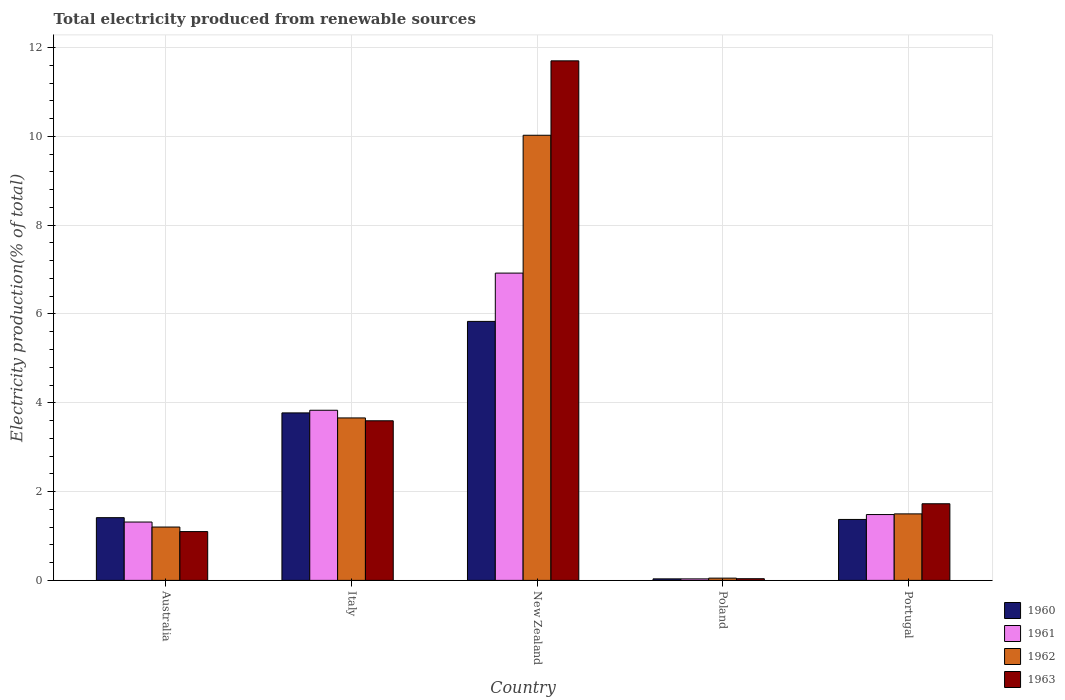Are the number of bars per tick equal to the number of legend labels?
Provide a short and direct response. Yes. Are the number of bars on each tick of the X-axis equal?
Keep it short and to the point. Yes. How many bars are there on the 3rd tick from the left?
Ensure brevity in your answer.  4. What is the total electricity produced in 1960 in Italy?
Make the answer very short. 3.77. Across all countries, what is the maximum total electricity produced in 1963?
Your answer should be very brief. 11.7. Across all countries, what is the minimum total electricity produced in 1963?
Provide a succinct answer. 0.04. In which country was the total electricity produced in 1963 maximum?
Your response must be concise. New Zealand. What is the total total electricity produced in 1961 in the graph?
Provide a short and direct response. 13.58. What is the difference between the total electricity produced in 1962 in Italy and that in Poland?
Your answer should be very brief. 3.61. What is the difference between the total electricity produced in 1960 in New Zealand and the total electricity produced in 1963 in Poland?
Offer a very short reply. 5.79. What is the average total electricity produced in 1961 per country?
Make the answer very short. 2.72. What is the difference between the total electricity produced of/in 1963 and total electricity produced of/in 1962 in Australia?
Provide a succinct answer. -0.1. In how many countries, is the total electricity produced in 1961 greater than 5.6 %?
Give a very brief answer. 1. What is the ratio of the total electricity produced in 1961 in Australia to that in New Zealand?
Offer a very short reply. 0.19. Is the total electricity produced in 1962 in Italy less than that in New Zealand?
Make the answer very short. Yes. Is the difference between the total electricity produced in 1963 in New Zealand and Poland greater than the difference between the total electricity produced in 1962 in New Zealand and Poland?
Your answer should be compact. Yes. What is the difference between the highest and the second highest total electricity produced in 1962?
Ensure brevity in your answer.  -8.53. What is the difference between the highest and the lowest total electricity produced in 1963?
Keep it short and to the point. 11.66. In how many countries, is the total electricity produced in 1962 greater than the average total electricity produced in 1962 taken over all countries?
Make the answer very short. 2. Is the sum of the total electricity produced in 1960 in Italy and Portugal greater than the maximum total electricity produced in 1963 across all countries?
Make the answer very short. No. How many bars are there?
Your answer should be very brief. 20. Are all the bars in the graph horizontal?
Make the answer very short. No. How many countries are there in the graph?
Ensure brevity in your answer.  5. Are the values on the major ticks of Y-axis written in scientific E-notation?
Give a very brief answer. No. Does the graph contain any zero values?
Provide a short and direct response. No. Where does the legend appear in the graph?
Offer a terse response. Bottom right. How many legend labels are there?
Keep it short and to the point. 4. What is the title of the graph?
Provide a succinct answer. Total electricity produced from renewable sources. What is the Electricity production(% of total) of 1960 in Australia?
Ensure brevity in your answer.  1.41. What is the Electricity production(% of total) of 1961 in Australia?
Keep it short and to the point. 1.31. What is the Electricity production(% of total) of 1962 in Australia?
Your answer should be compact. 1.2. What is the Electricity production(% of total) of 1963 in Australia?
Your answer should be compact. 1.1. What is the Electricity production(% of total) of 1960 in Italy?
Ensure brevity in your answer.  3.77. What is the Electricity production(% of total) of 1961 in Italy?
Keep it short and to the point. 3.83. What is the Electricity production(% of total) in 1962 in Italy?
Offer a terse response. 3.66. What is the Electricity production(% of total) of 1963 in Italy?
Your response must be concise. 3.59. What is the Electricity production(% of total) of 1960 in New Zealand?
Provide a succinct answer. 5.83. What is the Electricity production(% of total) in 1961 in New Zealand?
Your answer should be very brief. 6.92. What is the Electricity production(% of total) of 1962 in New Zealand?
Ensure brevity in your answer.  10.02. What is the Electricity production(% of total) of 1963 in New Zealand?
Provide a short and direct response. 11.7. What is the Electricity production(% of total) of 1960 in Poland?
Provide a succinct answer. 0.03. What is the Electricity production(% of total) of 1961 in Poland?
Give a very brief answer. 0.03. What is the Electricity production(% of total) of 1962 in Poland?
Your answer should be very brief. 0.05. What is the Electricity production(% of total) in 1963 in Poland?
Your response must be concise. 0.04. What is the Electricity production(% of total) in 1960 in Portugal?
Offer a terse response. 1.37. What is the Electricity production(% of total) of 1961 in Portugal?
Provide a succinct answer. 1.48. What is the Electricity production(% of total) in 1962 in Portugal?
Your answer should be compact. 1.5. What is the Electricity production(% of total) of 1963 in Portugal?
Your answer should be compact. 1.73. Across all countries, what is the maximum Electricity production(% of total) of 1960?
Provide a succinct answer. 5.83. Across all countries, what is the maximum Electricity production(% of total) in 1961?
Offer a very short reply. 6.92. Across all countries, what is the maximum Electricity production(% of total) in 1962?
Make the answer very short. 10.02. Across all countries, what is the maximum Electricity production(% of total) in 1963?
Ensure brevity in your answer.  11.7. Across all countries, what is the minimum Electricity production(% of total) in 1960?
Make the answer very short. 0.03. Across all countries, what is the minimum Electricity production(% of total) in 1961?
Your answer should be very brief. 0.03. Across all countries, what is the minimum Electricity production(% of total) of 1962?
Provide a short and direct response. 0.05. Across all countries, what is the minimum Electricity production(% of total) in 1963?
Provide a succinct answer. 0.04. What is the total Electricity production(% of total) of 1960 in the graph?
Ensure brevity in your answer.  12.42. What is the total Electricity production(% of total) in 1961 in the graph?
Provide a short and direct response. 13.58. What is the total Electricity production(% of total) in 1962 in the graph?
Your response must be concise. 16.43. What is the total Electricity production(% of total) of 1963 in the graph?
Provide a succinct answer. 18.16. What is the difference between the Electricity production(% of total) of 1960 in Australia and that in Italy?
Provide a short and direct response. -2.36. What is the difference between the Electricity production(% of total) in 1961 in Australia and that in Italy?
Provide a succinct answer. -2.52. What is the difference between the Electricity production(% of total) of 1962 in Australia and that in Italy?
Your answer should be compact. -2.46. What is the difference between the Electricity production(% of total) in 1963 in Australia and that in Italy?
Your answer should be compact. -2.5. What is the difference between the Electricity production(% of total) in 1960 in Australia and that in New Zealand?
Make the answer very short. -4.42. What is the difference between the Electricity production(% of total) of 1961 in Australia and that in New Zealand?
Give a very brief answer. -5.61. What is the difference between the Electricity production(% of total) in 1962 in Australia and that in New Zealand?
Your answer should be compact. -8.82. What is the difference between the Electricity production(% of total) in 1963 in Australia and that in New Zealand?
Your answer should be very brief. -10.6. What is the difference between the Electricity production(% of total) in 1960 in Australia and that in Poland?
Give a very brief answer. 1.38. What is the difference between the Electricity production(% of total) in 1961 in Australia and that in Poland?
Your answer should be compact. 1.28. What is the difference between the Electricity production(% of total) in 1962 in Australia and that in Poland?
Keep it short and to the point. 1.15. What is the difference between the Electricity production(% of total) in 1963 in Australia and that in Poland?
Provide a succinct answer. 1.06. What is the difference between the Electricity production(% of total) of 1960 in Australia and that in Portugal?
Give a very brief answer. 0.04. What is the difference between the Electricity production(% of total) of 1961 in Australia and that in Portugal?
Your response must be concise. -0.17. What is the difference between the Electricity production(% of total) of 1962 in Australia and that in Portugal?
Offer a terse response. -0.3. What is the difference between the Electricity production(% of total) in 1963 in Australia and that in Portugal?
Offer a terse response. -0.63. What is the difference between the Electricity production(% of total) in 1960 in Italy and that in New Zealand?
Your answer should be compact. -2.06. What is the difference between the Electricity production(% of total) of 1961 in Italy and that in New Zealand?
Your answer should be compact. -3.09. What is the difference between the Electricity production(% of total) in 1962 in Italy and that in New Zealand?
Provide a succinct answer. -6.37. What is the difference between the Electricity production(% of total) of 1963 in Italy and that in New Zealand?
Provide a short and direct response. -8.11. What is the difference between the Electricity production(% of total) in 1960 in Italy and that in Poland?
Offer a terse response. 3.74. What is the difference between the Electricity production(% of total) in 1961 in Italy and that in Poland?
Make the answer very short. 3.8. What is the difference between the Electricity production(% of total) in 1962 in Italy and that in Poland?
Ensure brevity in your answer.  3.61. What is the difference between the Electricity production(% of total) in 1963 in Italy and that in Poland?
Provide a succinct answer. 3.56. What is the difference between the Electricity production(% of total) of 1960 in Italy and that in Portugal?
Your response must be concise. 2.4. What is the difference between the Electricity production(% of total) of 1961 in Italy and that in Portugal?
Offer a very short reply. 2.35. What is the difference between the Electricity production(% of total) of 1962 in Italy and that in Portugal?
Keep it short and to the point. 2.16. What is the difference between the Electricity production(% of total) in 1963 in Italy and that in Portugal?
Offer a very short reply. 1.87. What is the difference between the Electricity production(% of total) of 1960 in New Zealand and that in Poland?
Your answer should be compact. 5.8. What is the difference between the Electricity production(% of total) of 1961 in New Zealand and that in Poland?
Provide a succinct answer. 6.89. What is the difference between the Electricity production(% of total) in 1962 in New Zealand and that in Poland?
Offer a very short reply. 9.97. What is the difference between the Electricity production(% of total) of 1963 in New Zealand and that in Poland?
Ensure brevity in your answer.  11.66. What is the difference between the Electricity production(% of total) of 1960 in New Zealand and that in Portugal?
Ensure brevity in your answer.  4.46. What is the difference between the Electricity production(% of total) of 1961 in New Zealand and that in Portugal?
Give a very brief answer. 5.44. What is the difference between the Electricity production(% of total) in 1962 in New Zealand and that in Portugal?
Offer a very short reply. 8.53. What is the difference between the Electricity production(% of total) of 1963 in New Zealand and that in Portugal?
Keep it short and to the point. 9.97. What is the difference between the Electricity production(% of total) of 1960 in Poland and that in Portugal?
Ensure brevity in your answer.  -1.34. What is the difference between the Electricity production(% of total) of 1961 in Poland and that in Portugal?
Keep it short and to the point. -1.45. What is the difference between the Electricity production(% of total) in 1962 in Poland and that in Portugal?
Offer a terse response. -1.45. What is the difference between the Electricity production(% of total) in 1963 in Poland and that in Portugal?
Your answer should be very brief. -1.69. What is the difference between the Electricity production(% of total) in 1960 in Australia and the Electricity production(% of total) in 1961 in Italy?
Your response must be concise. -2.42. What is the difference between the Electricity production(% of total) in 1960 in Australia and the Electricity production(% of total) in 1962 in Italy?
Give a very brief answer. -2.25. What is the difference between the Electricity production(% of total) in 1960 in Australia and the Electricity production(% of total) in 1963 in Italy?
Your answer should be very brief. -2.18. What is the difference between the Electricity production(% of total) of 1961 in Australia and the Electricity production(% of total) of 1962 in Italy?
Your response must be concise. -2.34. What is the difference between the Electricity production(% of total) of 1961 in Australia and the Electricity production(% of total) of 1963 in Italy?
Provide a succinct answer. -2.28. What is the difference between the Electricity production(% of total) in 1962 in Australia and the Electricity production(% of total) in 1963 in Italy?
Make the answer very short. -2.39. What is the difference between the Electricity production(% of total) in 1960 in Australia and the Electricity production(% of total) in 1961 in New Zealand?
Your answer should be compact. -5.51. What is the difference between the Electricity production(% of total) in 1960 in Australia and the Electricity production(% of total) in 1962 in New Zealand?
Offer a terse response. -8.61. What is the difference between the Electricity production(% of total) in 1960 in Australia and the Electricity production(% of total) in 1963 in New Zealand?
Keep it short and to the point. -10.29. What is the difference between the Electricity production(% of total) in 1961 in Australia and the Electricity production(% of total) in 1962 in New Zealand?
Keep it short and to the point. -8.71. What is the difference between the Electricity production(% of total) in 1961 in Australia and the Electricity production(% of total) in 1963 in New Zealand?
Give a very brief answer. -10.39. What is the difference between the Electricity production(% of total) of 1962 in Australia and the Electricity production(% of total) of 1963 in New Zealand?
Your response must be concise. -10.5. What is the difference between the Electricity production(% of total) in 1960 in Australia and the Electricity production(% of total) in 1961 in Poland?
Offer a very short reply. 1.38. What is the difference between the Electricity production(% of total) in 1960 in Australia and the Electricity production(% of total) in 1962 in Poland?
Offer a terse response. 1.36. What is the difference between the Electricity production(% of total) in 1960 in Australia and the Electricity production(% of total) in 1963 in Poland?
Keep it short and to the point. 1.37. What is the difference between the Electricity production(% of total) of 1961 in Australia and the Electricity production(% of total) of 1962 in Poland?
Give a very brief answer. 1.26. What is the difference between the Electricity production(% of total) in 1961 in Australia and the Electricity production(% of total) in 1963 in Poland?
Offer a very short reply. 1.28. What is the difference between the Electricity production(% of total) in 1962 in Australia and the Electricity production(% of total) in 1963 in Poland?
Offer a terse response. 1.16. What is the difference between the Electricity production(% of total) in 1960 in Australia and the Electricity production(% of total) in 1961 in Portugal?
Keep it short and to the point. -0.07. What is the difference between the Electricity production(% of total) in 1960 in Australia and the Electricity production(% of total) in 1962 in Portugal?
Keep it short and to the point. -0.09. What is the difference between the Electricity production(% of total) in 1960 in Australia and the Electricity production(% of total) in 1963 in Portugal?
Offer a terse response. -0.31. What is the difference between the Electricity production(% of total) in 1961 in Australia and the Electricity production(% of total) in 1962 in Portugal?
Provide a short and direct response. -0.18. What is the difference between the Electricity production(% of total) of 1961 in Australia and the Electricity production(% of total) of 1963 in Portugal?
Offer a very short reply. -0.41. What is the difference between the Electricity production(% of total) of 1962 in Australia and the Electricity production(% of total) of 1963 in Portugal?
Ensure brevity in your answer.  -0.52. What is the difference between the Electricity production(% of total) in 1960 in Italy and the Electricity production(% of total) in 1961 in New Zealand?
Provide a succinct answer. -3.15. What is the difference between the Electricity production(% of total) in 1960 in Italy and the Electricity production(% of total) in 1962 in New Zealand?
Provide a succinct answer. -6.25. What is the difference between the Electricity production(% of total) of 1960 in Italy and the Electricity production(% of total) of 1963 in New Zealand?
Your response must be concise. -7.93. What is the difference between the Electricity production(% of total) in 1961 in Italy and the Electricity production(% of total) in 1962 in New Zealand?
Your answer should be compact. -6.19. What is the difference between the Electricity production(% of total) of 1961 in Italy and the Electricity production(% of total) of 1963 in New Zealand?
Offer a terse response. -7.87. What is the difference between the Electricity production(% of total) of 1962 in Italy and the Electricity production(% of total) of 1963 in New Zealand?
Your response must be concise. -8.04. What is the difference between the Electricity production(% of total) of 1960 in Italy and the Electricity production(% of total) of 1961 in Poland?
Provide a succinct answer. 3.74. What is the difference between the Electricity production(% of total) in 1960 in Italy and the Electricity production(% of total) in 1962 in Poland?
Your answer should be compact. 3.72. What is the difference between the Electricity production(% of total) in 1960 in Italy and the Electricity production(% of total) in 1963 in Poland?
Provide a succinct answer. 3.73. What is the difference between the Electricity production(% of total) in 1961 in Italy and the Electricity production(% of total) in 1962 in Poland?
Ensure brevity in your answer.  3.78. What is the difference between the Electricity production(% of total) in 1961 in Italy and the Electricity production(% of total) in 1963 in Poland?
Keep it short and to the point. 3.79. What is the difference between the Electricity production(% of total) in 1962 in Italy and the Electricity production(% of total) in 1963 in Poland?
Ensure brevity in your answer.  3.62. What is the difference between the Electricity production(% of total) of 1960 in Italy and the Electricity production(% of total) of 1961 in Portugal?
Provide a succinct answer. 2.29. What is the difference between the Electricity production(% of total) in 1960 in Italy and the Electricity production(% of total) in 1962 in Portugal?
Your response must be concise. 2.27. What is the difference between the Electricity production(% of total) of 1960 in Italy and the Electricity production(% of total) of 1963 in Portugal?
Your answer should be very brief. 2.05. What is the difference between the Electricity production(% of total) in 1961 in Italy and the Electricity production(% of total) in 1962 in Portugal?
Your answer should be compact. 2.33. What is the difference between the Electricity production(% of total) in 1961 in Italy and the Electricity production(% of total) in 1963 in Portugal?
Offer a very short reply. 2.11. What is the difference between the Electricity production(% of total) of 1962 in Italy and the Electricity production(% of total) of 1963 in Portugal?
Your answer should be compact. 1.93. What is the difference between the Electricity production(% of total) of 1960 in New Zealand and the Electricity production(% of total) of 1961 in Poland?
Your response must be concise. 5.8. What is the difference between the Electricity production(% of total) of 1960 in New Zealand and the Electricity production(% of total) of 1962 in Poland?
Your response must be concise. 5.78. What is the difference between the Electricity production(% of total) in 1960 in New Zealand and the Electricity production(% of total) in 1963 in Poland?
Ensure brevity in your answer.  5.79. What is the difference between the Electricity production(% of total) of 1961 in New Zealand and the Electricity production(% of total) of 1962 in Poland?
Your answer should be very brief. 6.87. What is the difference between the Electricity production(% of total) in 1961 in New Zealand and the Electricity production(% of total) in 1963 in Poland?
Your answer should be compact. 6.88. What is the difference between the Electricity production(% of total) in 1962 in New Zealand and the Electricity production(% of total) in 1963 in Poland?
Your answer should be very brief. 9.99. What is the difference between the Electricity production(% of total) in 1960 in New Zealand and the Electricity production(% of total) in 1961 in Portugal?
Keep it short and to the point. 4.35. What is the difference between the Electricity production(% of total) in 1960 in New Zealand and the Electricity production(% of total) in 1962 in Portugal?
Offer a very short reply. 4.33. What is the difference between the Electricity production(% of total) in 1960 in New Zealand and the Electricity production(% of total) in 1963 in Portugal?
Make the answer very short. 4.11. What is the difference between the Electricity production(% of total) of 1961 in New Zealand and the Electricity production(% of total) of 1962 in Portugal?
Your answer should be very brief. 5.42. What is the difference between the Electricity production(% of total) in 1961 in New Zealand and the Electricity production(% of total) in 1963 in Portugal?
Offer a terse response. 5.19. What is the difference between the Electricity production(% of total) of 1962 in New Zealand and the Electricity production(% of total) of 1963 in Portugal?
Provide a succinct answer. 8.3. What is the difference between the Electricity production(% of total) of 1960 in Poland and the Electricity production(% of total) of 1961 in Portugal?
Offer a very short reply. -1.45. What is the difference between the Electricity production(% of total) in 1960 in Poland and the Electricity production(% of total) in 1962 in Portugal?
Your answer should be very brief. -1.46. What is the difference between the Electricity production(% of total) of 1960 in Poland and the Electricity production(% of total) of 1963 in Portugal?
Your response must be concise. -1.69. What is the difference between the Electricity production(% of total) in 1961 in Poland and the Electricity production(% of total) in 1962 in Portugal?
Your answer should be very brief. -1.46. What is the difference between the Electricity production(% of total) of 1961 in Poland and the Electricity production(% of total) of 1963 in Portugal?
Ensure brevity in your answer.  -1.69. What is the difference between the Electricity production(% of total) of 1962 in Poland and the Electricity production(% of total) of 1963 in Portugal?
Offer a terse response. -1.67. What is the average Electricity production(% of total) of 1960 per country?
Give a very brief answer. 2.48. What is the average Electricity production(% of total) of 1961 per country?
Offer a terse response. 2.72. What is the average Electricity production(% of total) in 1962 per country?
Ensure brevity in your answer.  3.29. What is the average Electricity production(% of total) in 1963 per country?
Your response must be concise. 3.63. What is the difference between the Electricity production(% of total) in 1960 and Electricity production(% of total) in 1961 in Australia?
Your answer should be compact. 0.1. What is the difference between the Electricity production(% of total) of 1960 and Electricity production(% of total) of 1962 in Australia?
Ensure brevity in your answer.  0.21. What is the difference between the Electricity production(% of total) in 1960 and Electricity production(% of total) in 1963 in Australia?
Give a very brief answer. 0.31. What is the difference between the Electricity production(% of total) of 1961 and Electricity production(% of total) of 1962 in Australia?
Offer a very short reply. 0.11. What is the difference between the Electricity production(% of total) of 1961 and Electricity production(% of total) of 1963 in Australia?
Offer a terse response. 0.21. What is the difference between the Electricity production(% of total) of 1962 and Electricity production(% of total) of 1963 in Australia?
Your response must be concise. 0.1. What is the difference between the Electricity production(% of total) in 1960 and Electricity production(% of total) in 1961 in Italy?
Make the answer very short. -0.06. What is the difference between the Electricity production(% of total) in 1960 and Electricity production(% of total) in 1962 in Italy?
Provide a succinct answer. 0.11. What is the difference between the Electricity production(% of total) of 1960 and Electricity production(% of total) of 1963 in Italy?
Offer a terse response. 0.18. What is the difference between the Electricity production(% of total) of 1961 and Electricity production(% of total) of 1962 in Italy?
Offer a very short reply. 0.17. What is the difference between the Electricity production(% of total) of 1961 and Electricity production(% of total) of 1963 in Italy?
Make the answer very short. 0.24. What is the difference between the Electricity production(% of total) in 1962 and Electricity production(% of total) in 1963 in Italy?
Your answer should be compact. 0.06. What is the difference between the Electricity production(% of total) of 1960 and Electricity production(% of total) of 1961 in New Zealand?
Offer a very short reply. -1.09. What is the difference between the Electricity production(% of total) in 1960 and Electricity production(% of total) in 1962 in New Zealand?
Ensure brevity in your answer.  -4.19. What is the difference between the Electricity production(% of total) in 1960 and Electricity production(% of total) in 1963 in New Zealand?
Your response must be concise. -5.87. What is the difference between the Electricity production(% of total) of 1961 and Electricity production(% of total) of 1962 in New Zealand?
Offer a terse response. -3.1. What is the difference between the Electricity production(% of total) of 1961 and Electricity production(% of total) of 1963 in New Zealand?
Your response must be concise. -4.78. What is the difference between the Electricity production(% of total) in 1962 and Electricity production(% of total) in 1963 in New Zealand?
Ensure brevity in your answer.  -1.68. What is the difference between the Electricity production(% of total) in 1960 and Electricity production(% of total) in 1961 in Poland?
Offer a terse response. 0. What is the difference between the Electricity production(% of total) in 1960 and Electricity production(% of total) in 1962 in Poland?
Ensure brevity in your answer.  -0.02. What is the difference between the Electricity production(% of total) in 1960 and Electricity production(% of total) in 1963 in Poland?
Your response must be concise. -0. What is the difference between the Electricity production(% of total) in 1961 and Electricity production(% of total) in 1962 in Poland?
Offer a terse response. -0.02. What is the difference between the Electricity production(% of total) of 1961 and Electricity production(% of total) of 1963 in Poland?
Make the answer very short. -0. What is the difference between the Electricity production(% of total) of 1962 and Electricity production(% of total) of 1963 in Poland?
Keep it short and to the point. 0.01. What is the difference between the Electricity production(% of total) in 1960 and Electricity production(% of total) in 1961 in Portugal?
Provide a succinct answer. -0.11. What is the difference between the Electricity production(% of total) in 1960 and Electricity production(% of total) in 1962 in Portugal?
Make the answer very short. -0.13. What is the difference between the Electricity production(% of total) of 1960 and Electricity production(% of total) of 1963 in Portugal?
Give a very brief answer. -0.35. What is the difference between the Electricity production(% of total) in 1961 and Electricity production(% of total) in 1962 in Portugal?
Give a very brief answer. -0.02. What is the difference between the Electricity production(% of total) in 1961 and Electricity production(% of total) in 1963 in Portugal?
Make the answer very short. -0.24. What is the difference between the Electricity production(% of total) in 1962 and Electricity production(% of total) in 1963 in Portugal?
Offer a terse response. -0.23. What is the ratio of the Electricity production(% of total) in 1960 in Australia to that in Italy?
Provide a succinct answer. 0.37. What is the ratio of the Electricity production(% of total) of 1961 in Australia to that in Italy?
Keep it short and to the point. 0.34. What is the ratio of the Electricity production(% of total) of 1962 in Australia to that in Italy?
Give a very brief answer. 0.33. What is the ratio of the Electricity production(% of total) in 1963 in Australia to that in Italy?
Give a very brief answer. 0.31. What is the ratio of the Electricity production(% of total) of 1960 in Australia to that in New Zealand?
Your answer should be very brief. 0.24. What is the ratio of the Electricity production(% of total) in 1961 in Australia to that in New Zealand?
Your answer should be very brief. 0.19. What is the ratio of the Electricity production(% of total) in 1962 in Australia to that in New Zealand?
Ensure brevity in your answer.  0.12. What is the ratio of the Electricity production(% of total) in 1963 in Australia to that in New Zealand?
Provide a short and direct response. 0.09. What is the ratio of the Electricity production(% of total) of 1960 in Australia to that in Poland?
Give a very brief answer. 41.37. What is the ratio of the Electricity production(% of total) of 1961 in Australia to that in Poland?
Keep it short and to the point. 38.51. What is the ratio of the Electricity production(% of total) in 1962 in Australia to that in Poland?
Your answer should be compact. 23.61. What is the ratio of the Electricity production(% of total) of 1963 in Australia to that in Poland?
Your answer should be compact. 29. What is the ratio of the Electricity production(% of total) of 1960 in Australia to that in Portugal?
Your response must be concise. 1.03. What is the ratio of the Electricity production(% of total) of 1961 in Australia to that in Portugal?
Give a very brief answer. 0.89. What is the ratio of the Electricity production(% of total) of 1962 in Australia to that in Portugal?
Your answer should be compact. 0.8. What is the ratio of the Electricity production(% of total) of 1963 in Australia to that in Portugal?
Ensure brevity in your answer.  0.64. What is the ratio of the Electricity production(% of total) in 1960 in Italy to that in New Zealand?
Offer a terse response. 0.65. What is the ratio of the Electricity production(% of total) in 1961 in Italy to that in New Zealand?
Keep it short and to the point. 0.55. What is the ratio of the Electricity production(% of total) of 1962 in Italy to that in New Zealand?
Offer a terse response. 0.36. What is the ratio of the Electricity production(% of total) of 1963 in Italy to that in New Zealand?
Make the answer very short. 0.31. What is the ratio of the Electricity production(% of total) in 1960 in Italy to that in Poland?
Your answer should be very brief. 110.45. What is the ratio of the Electricity production(% of total) in 1961 in Italy to that in Poland?
Your answer should be very brief. 112.3. What is the ratio of the Electricity production(% of total) in 1962 in Italy to that in Poland?
Your answer should be compact. 71.88. What is the ratio of the Electricity production(% of total) of 1963 in Italy to that in Poland?
Make the answer very short. 94.84. What is the ratio of the Electricity production(% of total) in 1960 in Italy to that in Portugal?
Make the answer very short. 2.75. What is the ratio of the Electricity production(% of total) in 1961 in Italy to that in Portugal?
Provide a short and direct response. 2.58. What is the ratio of the Electricity production(% of total) in 1962 in Italy to that in Portugal?
Keep it short and to the point. 2.44. What is the ratio of the Electricity production(% of total) in 1963 in Italy to that in Portugal?
Keep it short and to the point. 2.08. What is the ratio of the Electricity production(% of total) in 1960 in New Zealand to that in Poland?
Your answer should be compact. 170.79. What is the ratio of the Electricity production(% of total) of 1961 in New Zealand to that in Poland?
Offer a terse response. 202.83. What is the ratio of the Electricity production(% of total) in 1962 in New Zealand to that in Poland?
Provide a succinct answer. 196.95. What is the ratio of the Electricity production(% of total) in 1963 in New Zealand to that in Poland?
Your answer should be compact. 308.73. What is the ratio of the Electricity production(% of total) in 1960 in New Zealand to that in Portugal?
Provide a succinct answer. 4.25. What is the ratio of the Electricity production(% of total) of 1961 in New Zealand to that in Portugal?
Keep it short and to the point. 4.67. What is the ratio of the Electricity production(% of total) of 1962 in New Zealand to that in Portugal?
Your answer should be compact. 6.69. What is the ratio of the Electricity production(% of total) in 1963 in New Zealand to that in Portugal?
Your answer should be compact. 6.78. What is the ratio of the Electricity production(% of total) in 1960 in Poland to that in Portugal?
Ensure brevity in your answer.  0.02. What is the ratio of the Electricity production(% of total) of 1961 in Poland to that in Portugal?
Provide a succinct answer. 0.02. What is the ratio of the Electricity production(% of total) of 1962 in Poland to that in Portugal?
Your response must be concise. 0.03. What is the ratio of the Electricity production(% of total) in 1963 in Poland to that in Portugal?
Offer a very short reply. 0.02. What is the difference between the highest and the second highest Electricity production(% of total) in 1960?
Make the answer very short. 2.06. What is the difference between the highest and the second highest Electricity production(% of total) of 1961?
Make the answer very short. 3.09. What is the difference between the highest and the second highest Electricity production(% of total) of 1962?
Your answer should be very brief. 6.37. What is the difference between the highest and the second highest Electricity production(% of total) of 1963?
Offer a terse response. 8.11. What is the difference between the highest and the lowest Electricity production(% of total) in 1960?
Give a very brief answer. 5.8. What is the difference between the highest and the lowest Electricity production(% of total) in 1961?
Offer a terse response. 6.89. What is the difference between the highest and the lowest Electricity production(% of total) of 1962?
Give a very brief answer. 9.97. What is the difference between the highest and the lowest Electricity production(% of total) of 1963?
Provide a succinct answer. 11.66. 